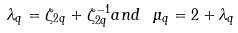<formula> <loc_0><loc_0><loc_500><loc_500>\lambda _ { q } = \zeta _ { 2 q } + \zeta _ { 2 q } ^ { - 1 } a n d \ \mu _ { q } = 2 + \lambda _ { q }</formula> 